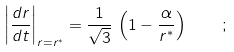<formula> <loc_0><loc_0><loc_500><loc_500>\left | \frac { d r } { d t } \right | _ { r = r ^ { * } } = \frac { 1 } { \sqrt { 3 } } \, \left ( 1 - \frac { \alpha } { r ^ { * } } \right ) \quad ;</formula> 